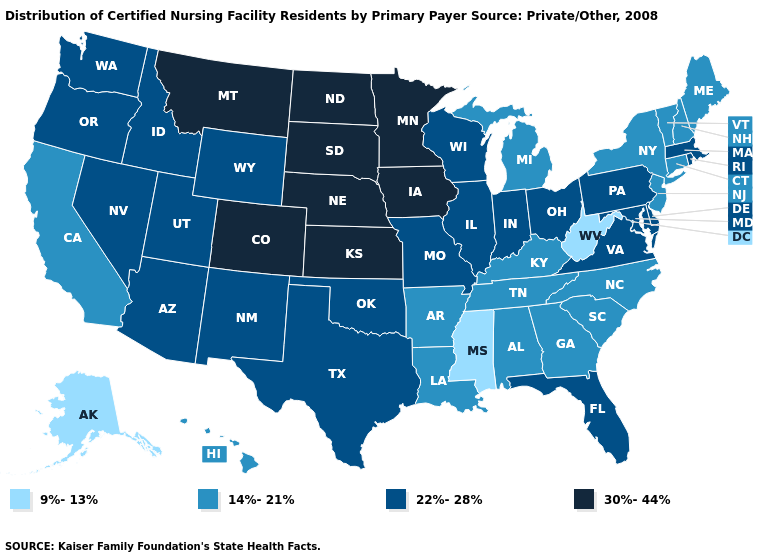Is the legend a continuous bar?
Give a very brief answer. No. What is the value of Arizona?
Give a very brief answer. 22%-28%. Among the states that border Wisconsin , does Illinois have the lowest value?
Give a very brief answer. No. Which states have the lowest value in the USA?
Short answer required. Alaska, Mississippi, West Virginia. Among the states that border New Hampshire , which have the highest value?
Be succinct. Massachusetts. How many symbols are there in the legend?
Answer briefly. 4. What is the highest value in the Northeast ?
Be succinct. 22%-28%. Does the first symbol in the legend represent the smallest category?
Concise answer only. Yes. Does Alaska have the lowest value in the West?
Write a very short answer. Yes. What is the value of Louisiana?
Give a very brief answer. 14%-21%. What is the lowest value in the USA?
Be succinct. 9%-13%. Name the states that have a value in the range 14%-21%?
Give a very brief answer. Alabama, Arkansas, California, Connecticut, Georgia, Hawaii, Kentucky, Louisiana, Maine, Michigan, New Hampshire, New Jersey, New York, North Carolina, South Carolina, Tennessee, Vermont. What is the lowest value in states that border California?
Answer briefly. 22%-28%. What is the value of Delaware?
Quick response, please. 22%-28%. What is the highest value in the West ?
Write a very short answer. 30%-44%. 